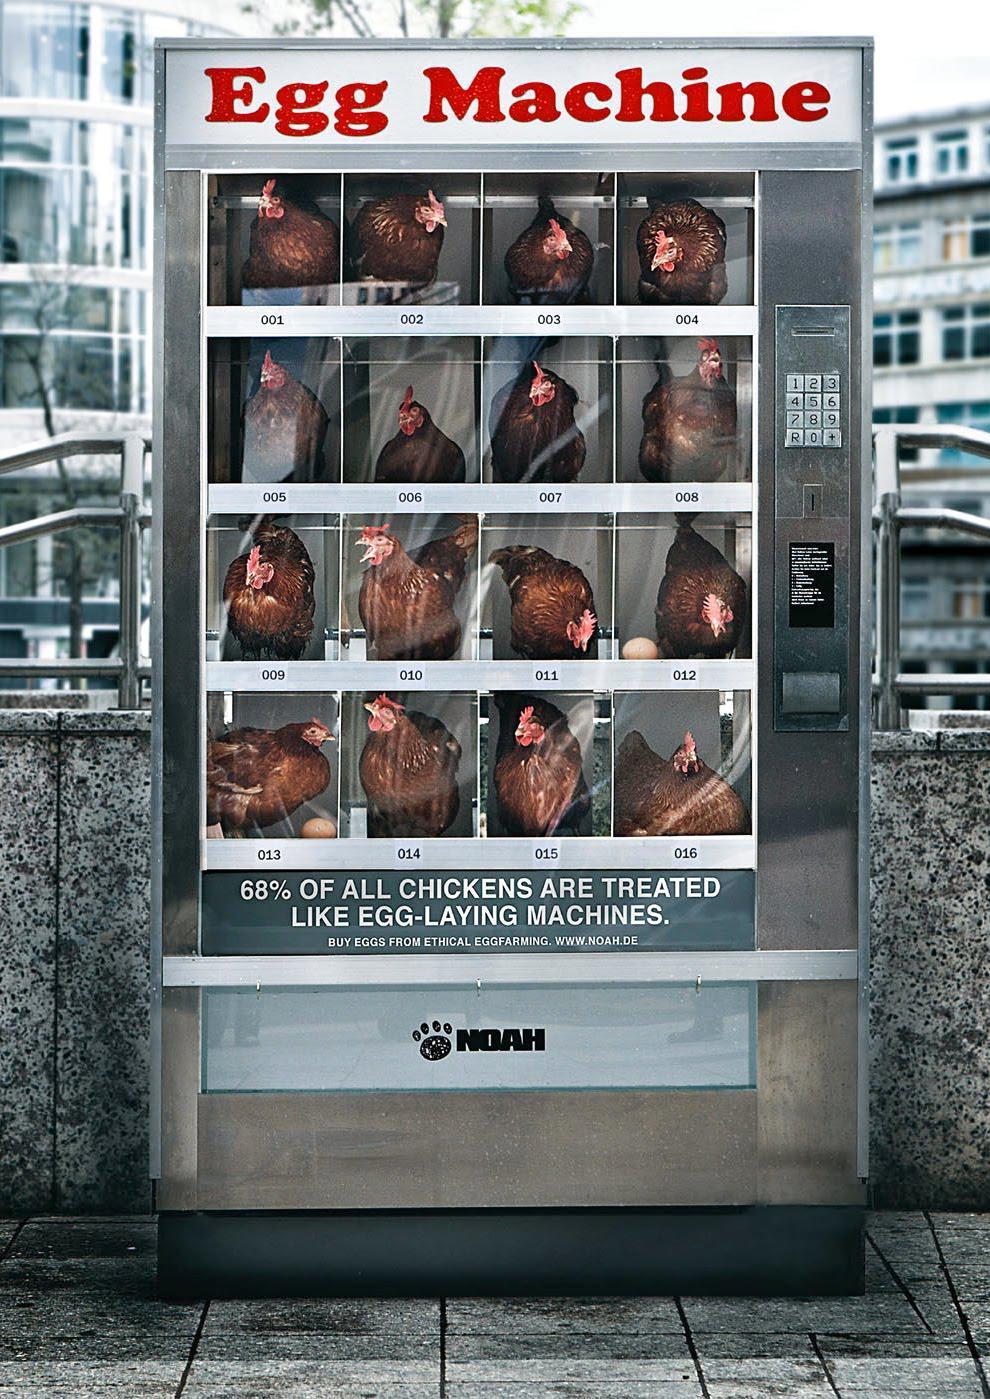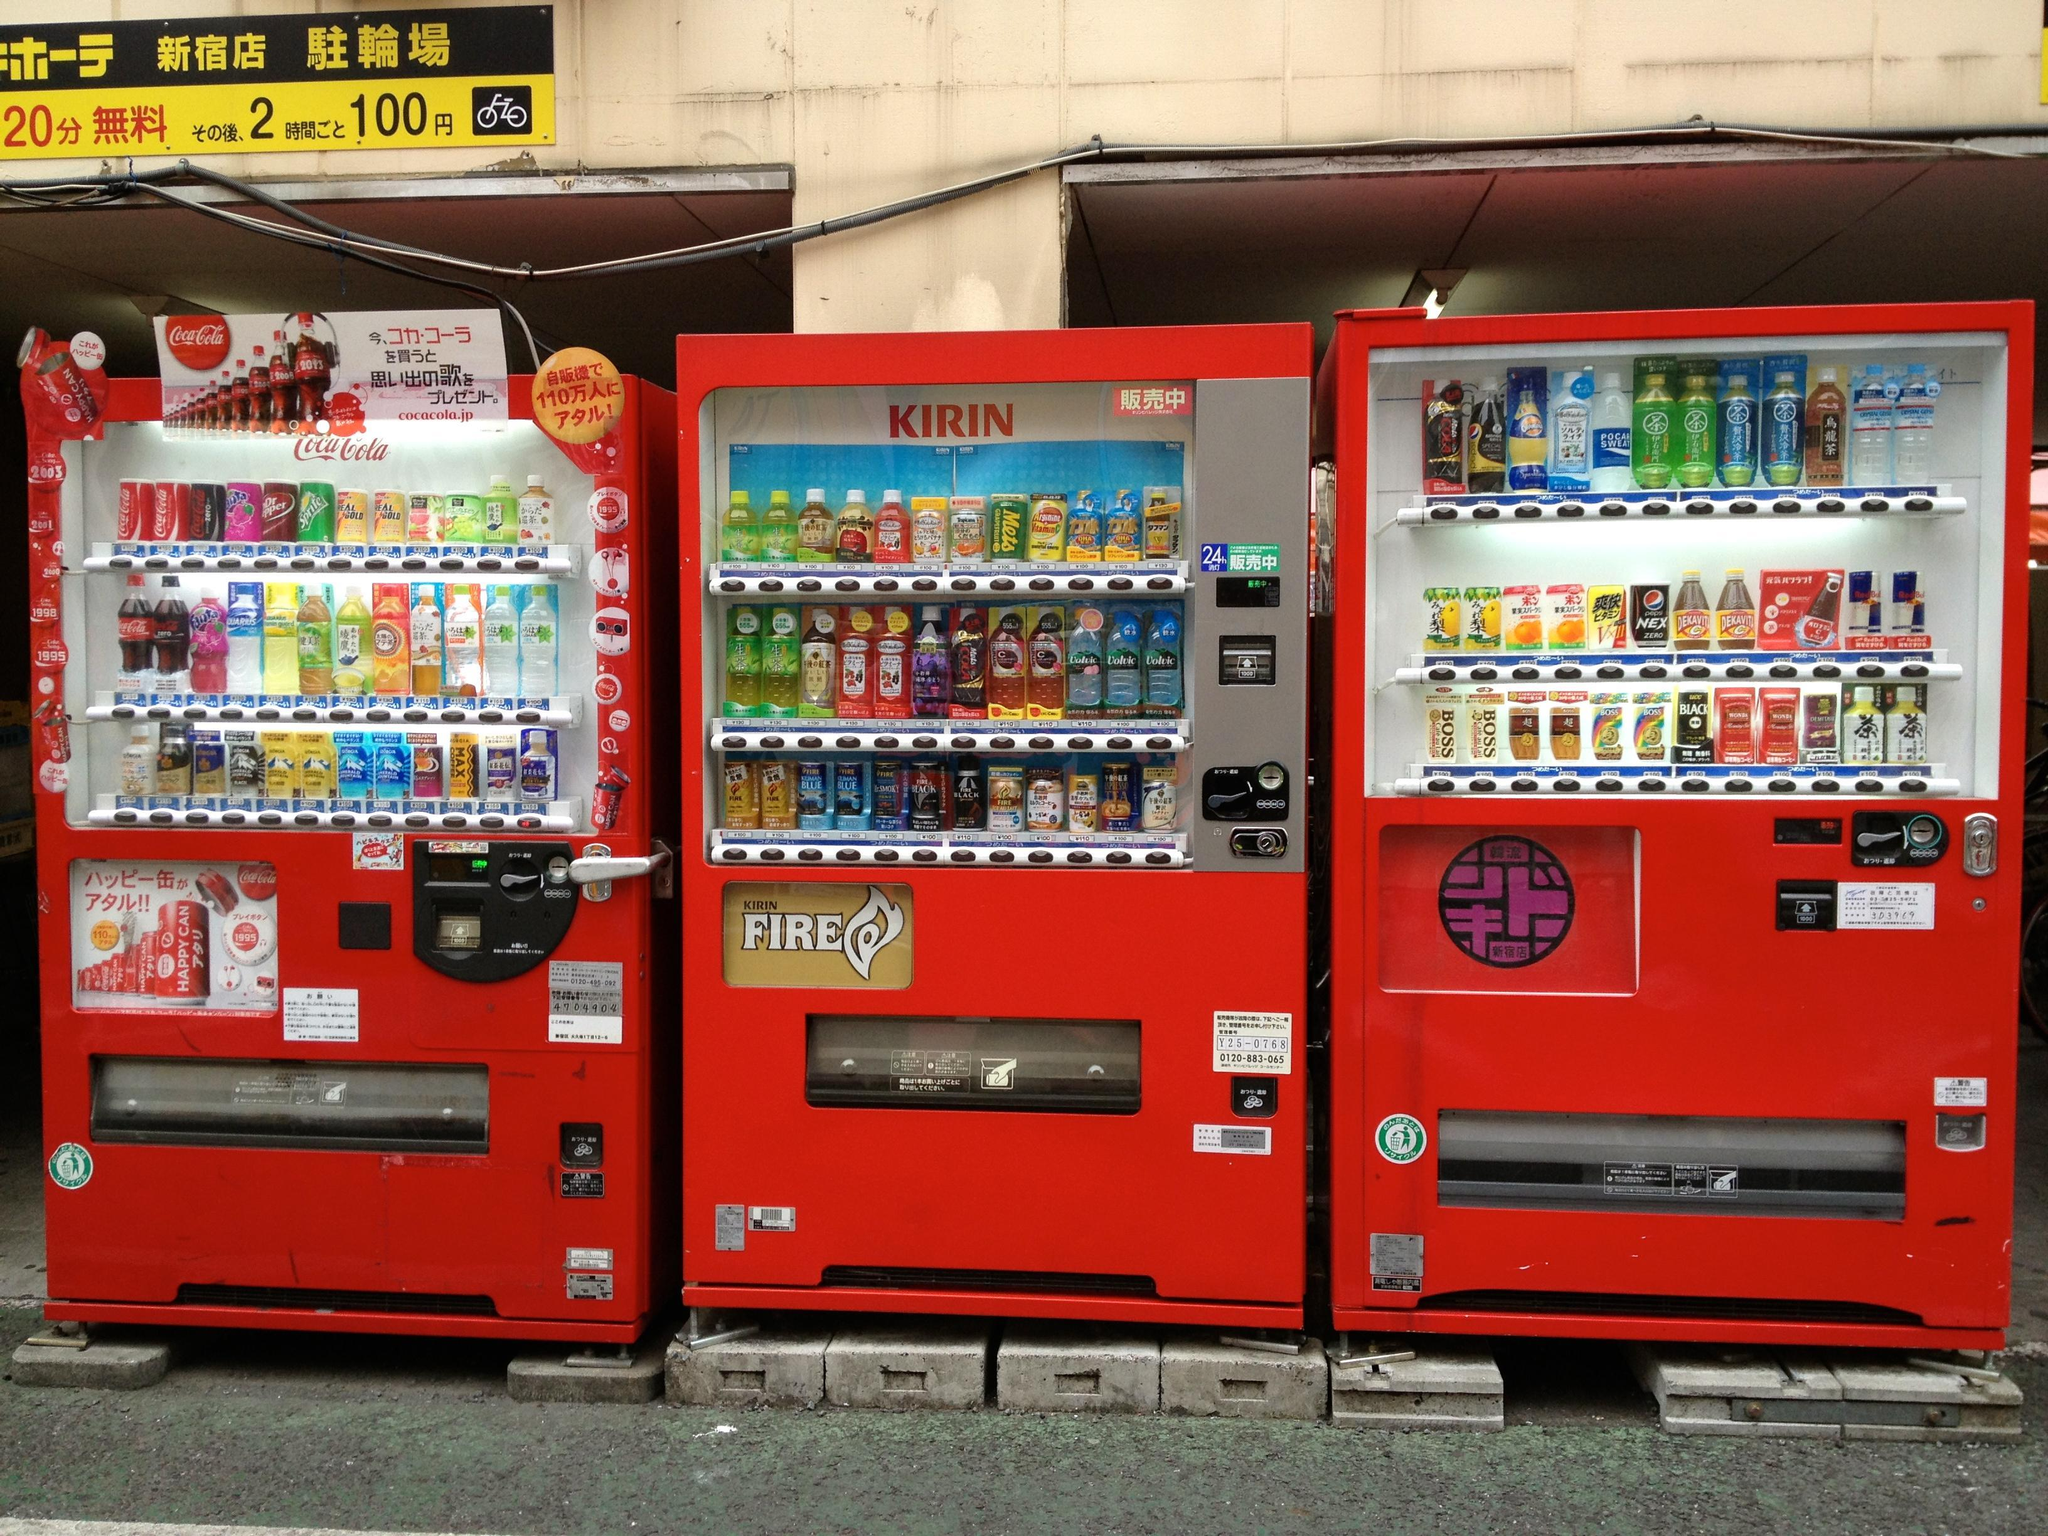The first image is the image on the left, the second image is the image on the right. Analyze the images presented: Is the assertion "The vending machine in the left image sells eggs, and does not have visible chickens in it." valid? Answer yes or no. No. The first image is the image on the left, the second image is the image on the right. Given the left and right images, does the statement "There is at least one red vending machine in full view that accepts cash to dispense the food or drink." hold true? Answer yes or no. Yes. 